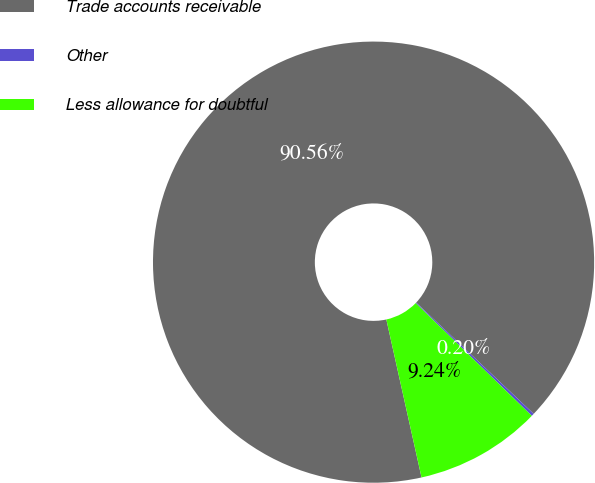Convert chart to OTSL. <chart><loc_0><loc_0><loc_500><loc_500><pie_chart><fcel>Trade accounts receivable<fcel>Other<fcel>Less allowance for doubtful<nl><fcel>90.56%<fcel>0.2%<fcel>9.24%<nl></chart> 